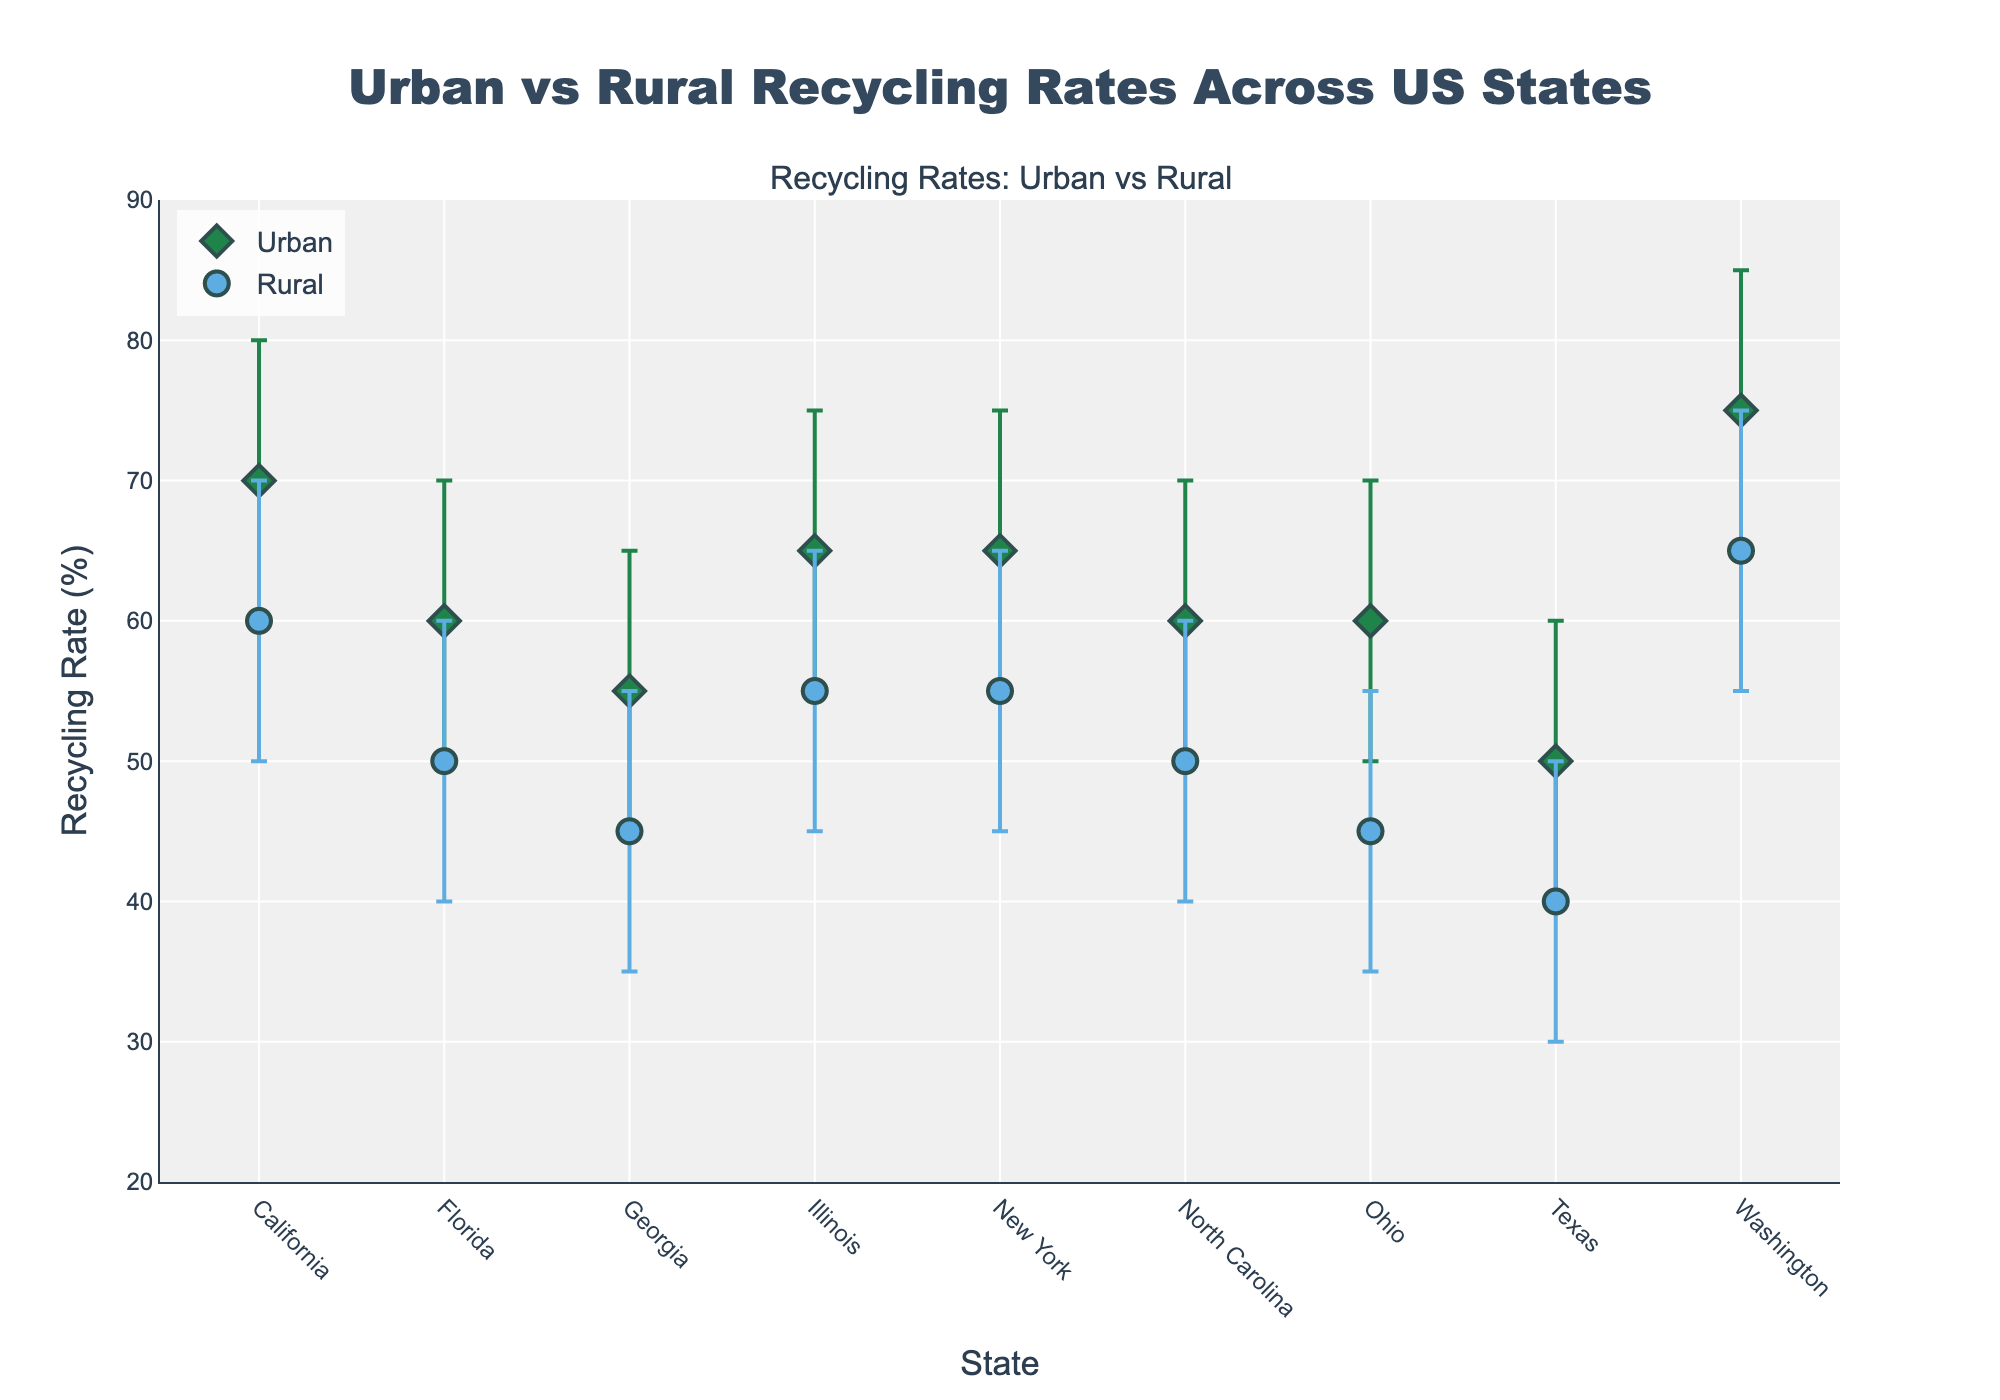What does the title of the plot say? The title is prominently displayed at the top center of the plot. It reads "Urban vs Rural Recycling Rates Across US States." This title indicates that the plot is showing recycling rates in both urban and rural areas across various states in the US.
Answer: Urban vs Rural Recycling Rates Across US States Which area (urban or rural) does California have a higher maximum recycling rate? The maximum recycling rate is indicated by the highest point of the range for each state. For California, the urban area has a maximum recycling rate of 80%, while the rural area has a maximum recycling rate of 70%.
Answer: Urban What is the range of recycling rates in New York's rural areas? The range is defined by the difference between the maximum and minimum recycling rates. For New York's rural areas, the minimum recycling rate is 45% and the maximum is 65%. Thus, the range is 65% - 45% = 20%.
Answer: 20% Which state has the highest mid-point recycling rate for urban areas? The mid-point recycling rate for urban areas can be determined from the position of the markers on the y-axis. Washington has the highest mid-point recycling rate for its urban area at 75%.
Answer: Washington Compare the minimum recycling rates between Texas's urban and rural areas. The minimum recycling rates are represented by the lowest points in their respective ranges. Texas has a minimum recycling rate of 40% in urban areas and 30% in rural areas. Therefore, the urban minimum is higher.
Answer: Urban is higher Which area, urban or rural, has a generally wider range of recycling rates in Illinois? The width of the range is the difference between the maximum and minimum rates. For Illinois, the urban area range is 70% - 55% = 20%, and the rural area range is 65% - 45% = 20%. Both ranges are equal; however, upon checking the markers more closely, the visual weights indicate a similar spread without a clear wider range.
Answer: Equal What's the recycling rate difference between the urban and rural areas in North Carolina at their maximum values? The maximum recycling rate for North Carolina's urban area is 70%, while the maximum for the rural area is 60%. The difference is 70% - 60% = 10%.
Answer: 10% In which state is the disparity between urban and rural mid-point recycling rates the smallest? The disparity can be found by comparing the mid-points of urban and rural areas in each state. Illinois has mid-point recycling rates of 65% (urban) and 55% (rural), leading to a disparity of 65% - 55% = 10%, which seems to be tied with North Carolina's disparity (55% urban vs. 50% rural). Direct visual reference to the plot would help confirm the smallest disparity.
Answer: Likely Illinois or North Carolina How many states have a minimum recycling rate of 50% or greater in their urban areas? From the plot, we count the number of states where the minimum recycling rate for urban areas is at least 50%. These states are California, New York, Florida, Illinois, and North Carolina.
Answer: 5 